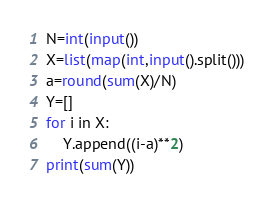<code> <loc_0><loc_0><loc_500><loc_500><_Python_>N=int(input())
X=list(map(int,input().split()))
a=round(sum(X)/N)
Y=[]
for i in X:
    Y.append((i-a)**2)
print(sum(Y))</code> 